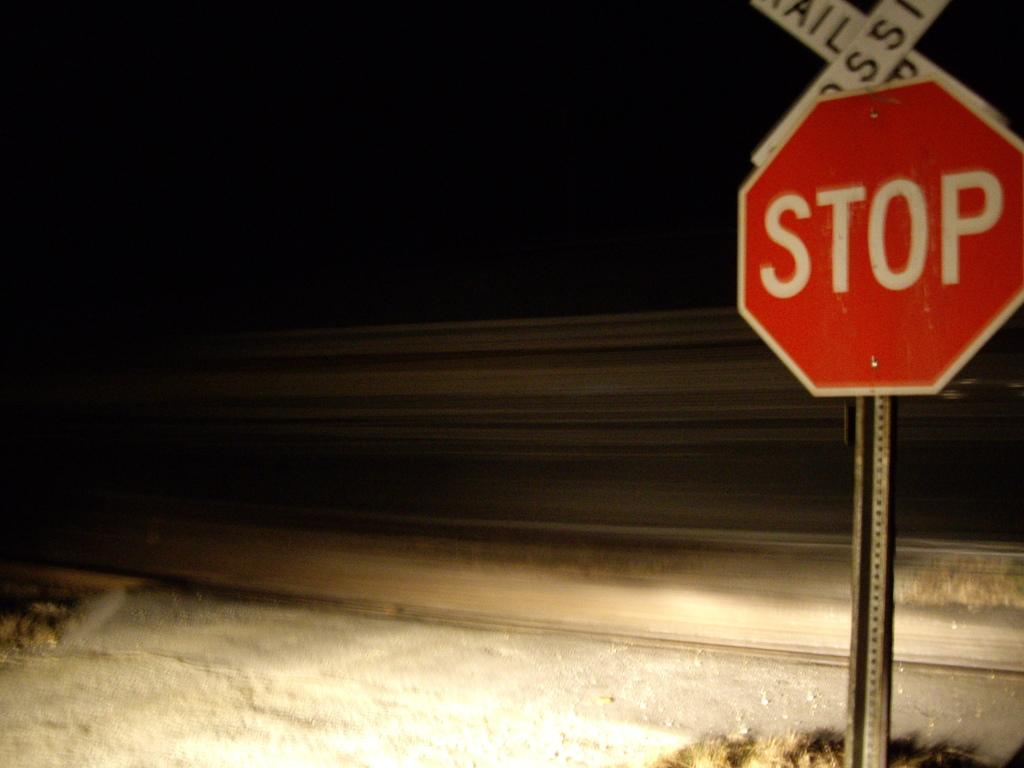<image>
Describe the image concisely. a stop sign that is outside in the dark 